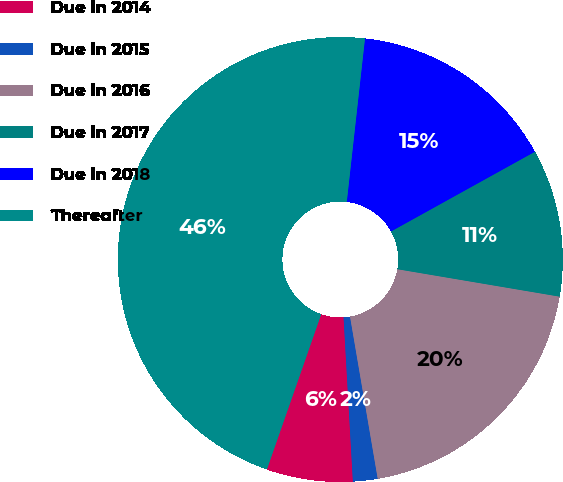Convert chart. <chart><loc_0><loc_0><loc_500><loc_500><pie_chart><fcel>Due in 2014<fcel>Due in 2015<fcel>Due in 2016<fcel>Due in 2017<fcel>Due in 2018<fcel>Thereafter<nl><fcel>6.26%<fcel>1.79%<fcel>19.64%<fcel>10.72%<fcel>15.18%<fcel>46.41%<nl></chart> 